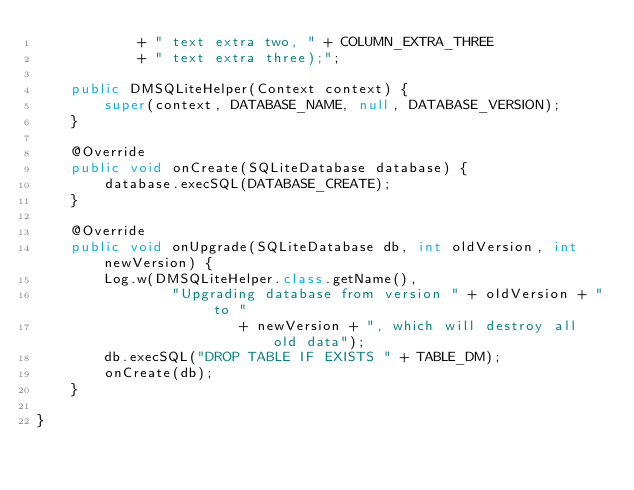Convert code to text. <code><loc_0><loc_0><loc_500><loc_500><_Java_>            + " text extra two, " + COLUMN_EXTRA_THREE
            + " text extra three);";

    public DMSQLiteHelper(Context context) {
        super(context, DATABASE_NAME, null, DATABASE_VERSION);
    }

    @Override
    public void onCreate(SQLiteDatabase database) {
        database.execSQL(DATABASE_CREATE);
    }

    @Override
    public void onUpgrade(SQLiteDatabase db, int oldVersion, int newVersion) {
        Log.w(DMSQLiteHelper.class.getName(),
                "Upgrading database from version " + oldVersion + " to "
                        + newVersion + ", which will destroy all old data");
        db.execSQL("DROP TABLE IF EXISTS " + TABLE_DM);
        onCreate(db);
    }

}</code> 